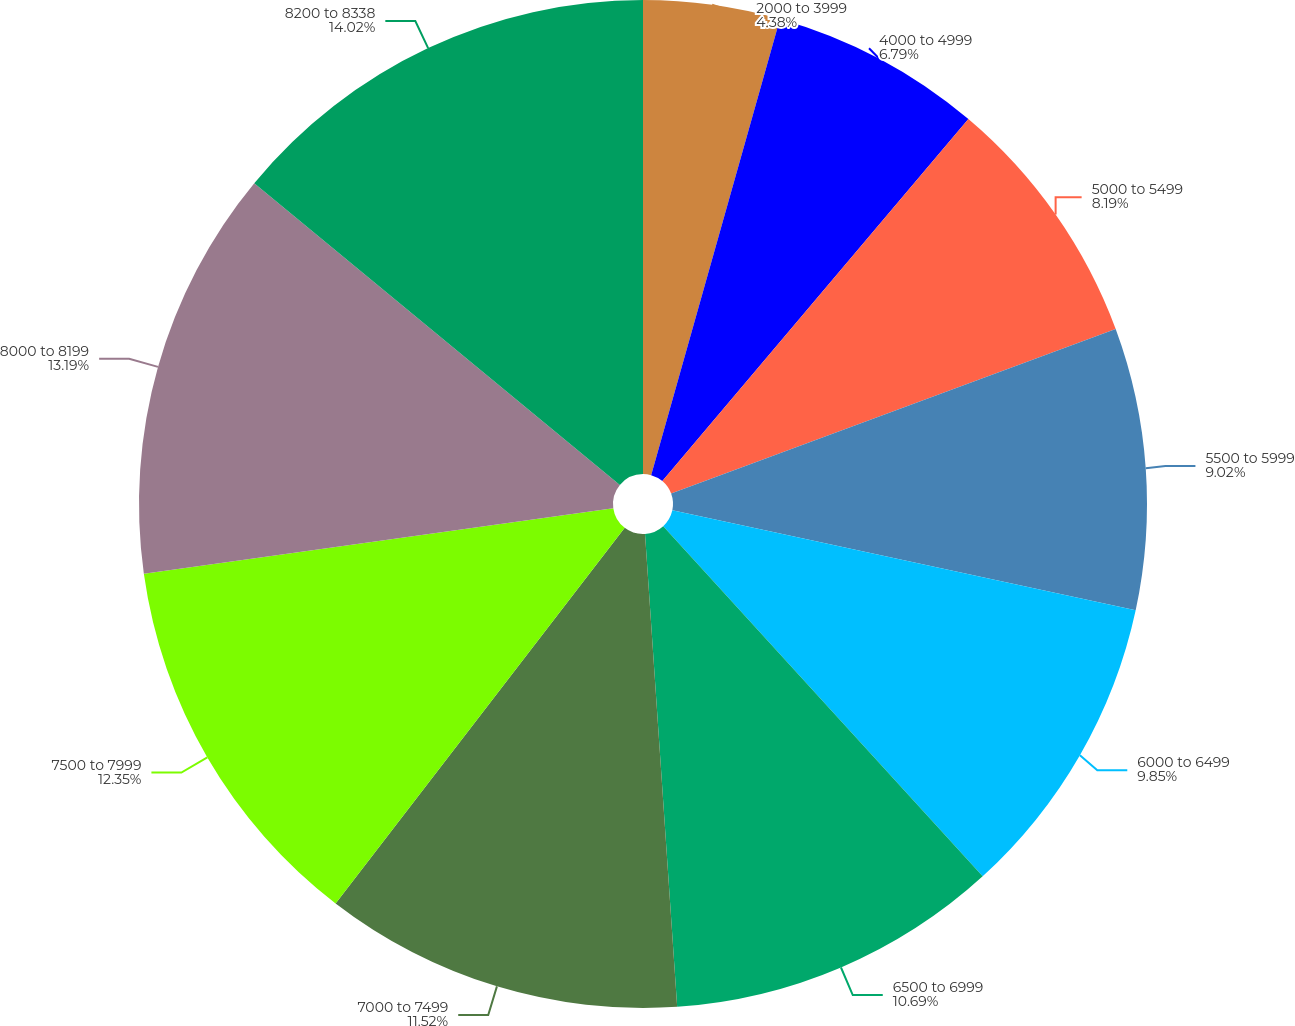Convert chart. <chart><loc_0><loc_0><loc_500><loc_500><pie_chart><fcel>2000 to 3999<fcel>4000 to 4999<fcel>5000 to 5499<fcel>5500 to 5999<fcel>6000 to 6499<fcel>6500 to 6999<fcel>7000 to 7499<fcel>7500 to 7999<fcel>8000 to 8199<fcel>8200 to 8338<nl><fcel>4.38%<fcel>6.79%<fcel>8.19%<fcel>9.02%<fcel>9.85%<fcel>10.69%<fcel>11.52%<fcel>12.35%<fcel>13.19%<fcel>14.02%<nl></chart> 